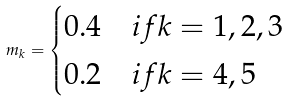<formula> <loc_0><loc_0><loc_500><loc_500>m _ { k } = \begin{cases} 0 . 4 & i f k = 1 , 2 , 3 \\ 0 . 2 & i f k = 4 , 5 \end{cases}</formula> 